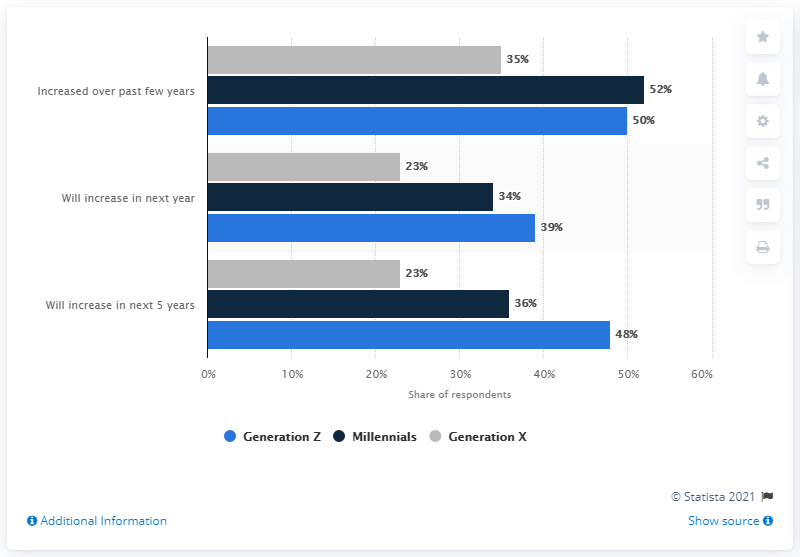List a handful of essential elements in this visual. Generation Z is expected to have the largest share of increased usage of e-mail in the upcoming year. The age group most likely to increase their usage of e-mail in the coming year is 39 years old. 